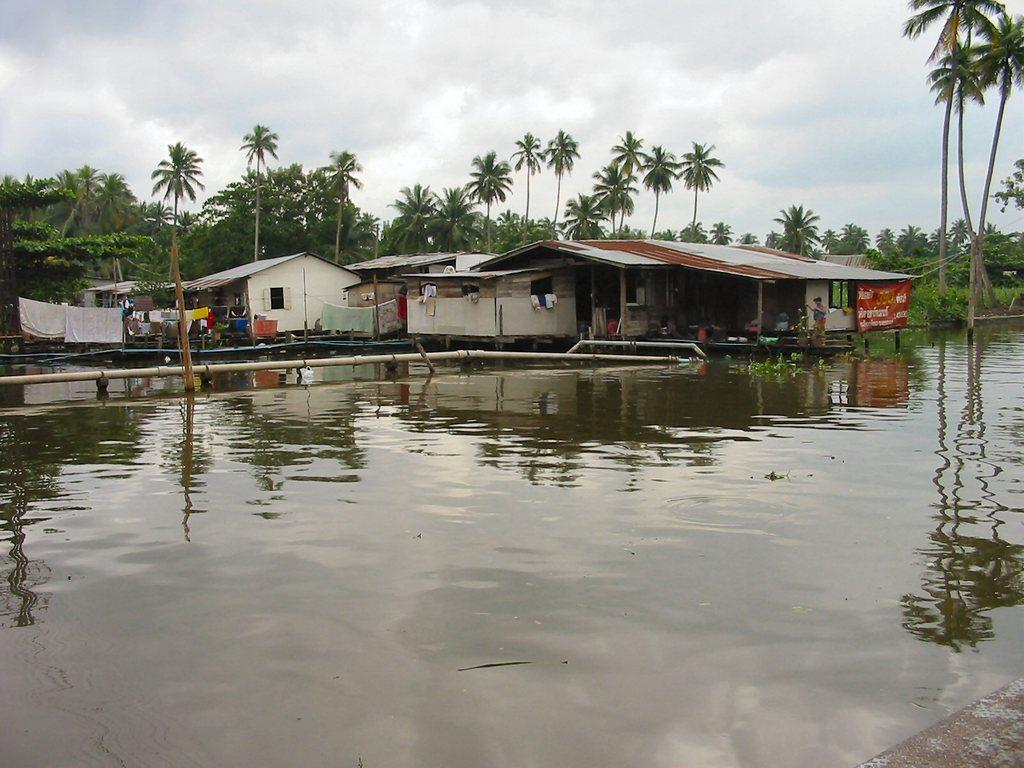What is the main feature of the image? The main feature of the image is water flooding. What structures can be seen in the image? There are buildings in the image. What type of vegetation is visible in the background? There are trees in the background of the image. What is the condition of the sky in the image? The sky is clear in the image. Can you see a playground in the image? There is no playground present in the image. How many toes are visible in the image? There are no toes visible in the image. 